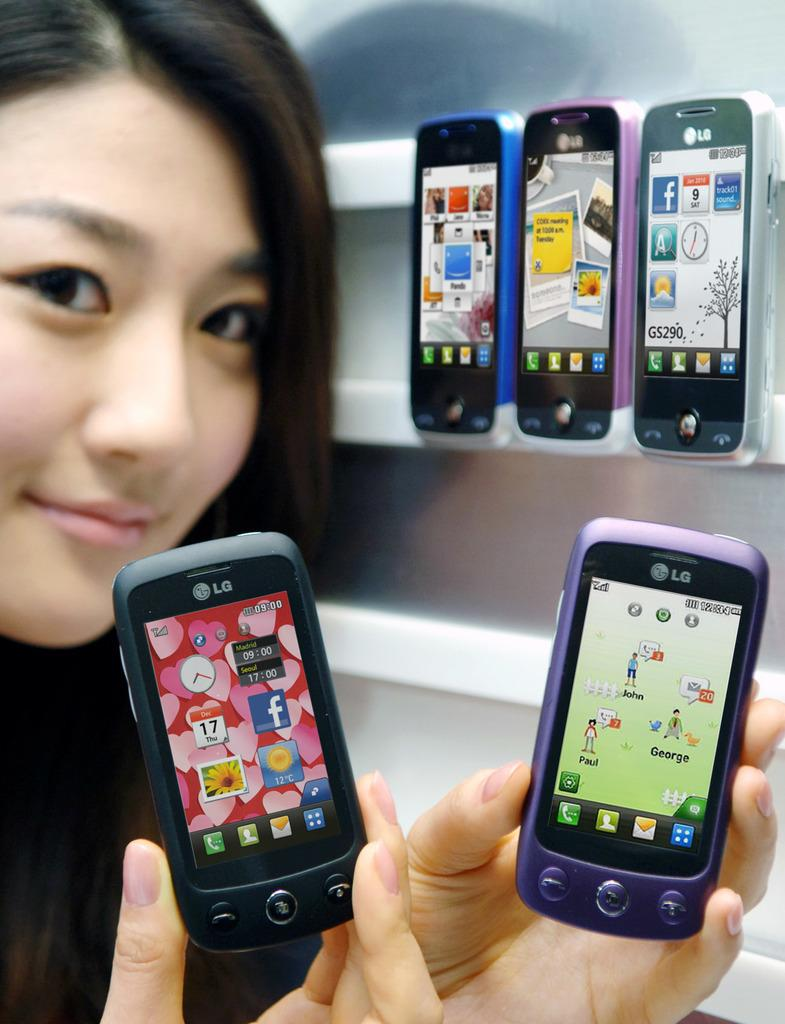<image>
Create a compact narrative representing the image presented. A woman holding up two phones made by LG. 